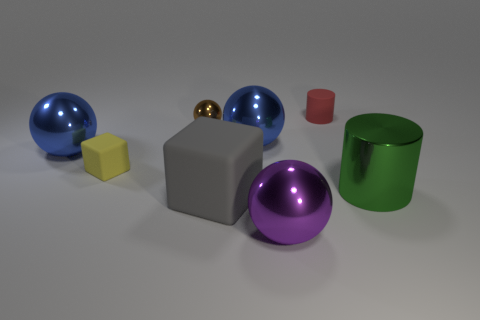There is a matte object that is on the right side of the sphere that is in front of the large thing to the right of the purple metallic sphere; what is its shape?
Make the answer very short. Cylinder. Does the red cylinder have the same size as the matte block to the left of the big gray rubber block?
Make the answer very short. Yes. There is a matte thing that is behind the large green object and right of the tiny brown metallic thing; what is its shape?
Offer a very short reply. Cylinder. What number of small objects are purple metallic blocks or green objects?
Give a very brief answer. 0. Is the number of yellow cubes behind the tiny shiny thing the same as the number of large blue things that are right of the tiny yellow object?
Offer a very short reply. No. What number of other things are there of the same color as the rubber cylinder?
Your response must be concise. 0. Is the number of yellow things to the right of the small brown metal thing the same as the number of big gray metal cylinders?
Keep it short and to the point. Yes. Is the size of the yellow matte thing the same as the gray matte cube?
Give a very brief answer. No. There is a large thing that is both in front of the large metal cylinder and behind the purple thing; what material is it?
Provide a short and direct response. Rubber. How many tiny yellow things have the same shape as the gray matte thing?
Ensure brevity in your answer.  1. 